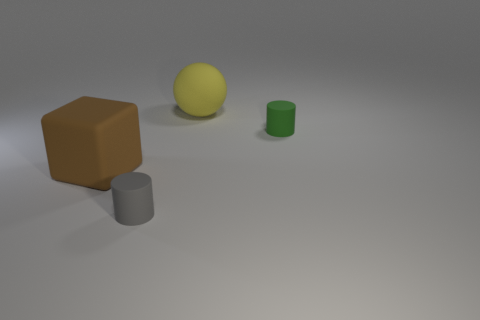Subtract all green balls. Subtract all gray blocks. How many balls are left? 1 Add 1 small green rubber things. How many objects exist? 5 Subtract all spheres. How many objects are left? 3 Subtract 0 green balls. How many objects are left? 4 Subtract all small green cylinders. Subtract all big things. How many objects are left? 1 Add 4 small rubber cylinders. How many small rubber cylinders are left? 6 Add 3 small gray cylinders. How many small gray cylinders exist? 4 